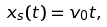<formula> <loc_0><loc_0><loc_500><loc_500>x _ { s } ( t ) = v _ { 0 } t ,</formula> 